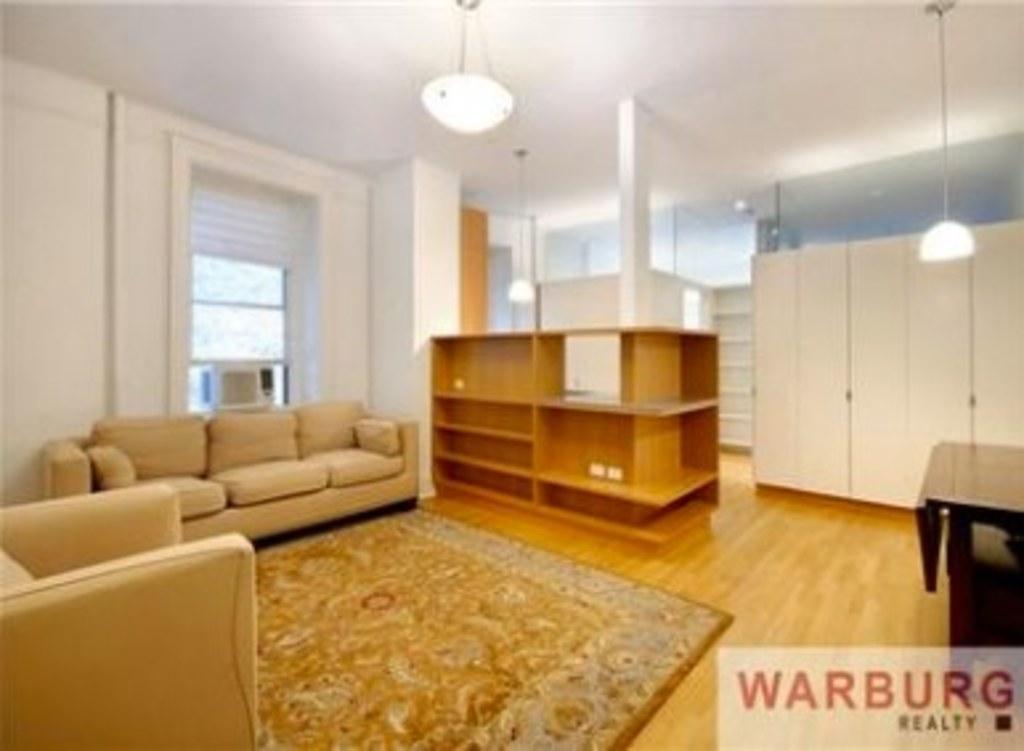Can you describe this image briefly? As we can see in the image there is a white color wall, sofas, light and a mat. 